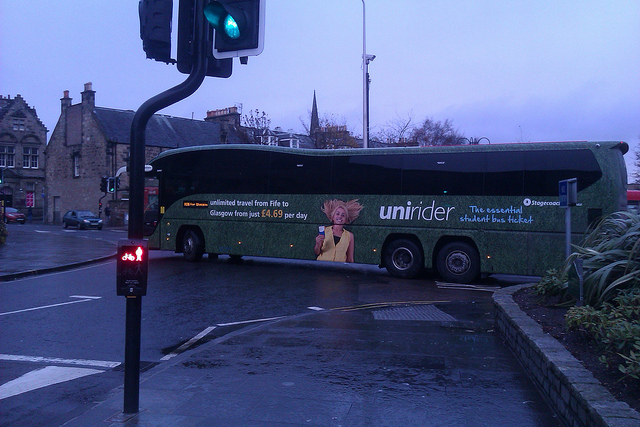How many cars can be seen in the image? In the image, there are a total of two cars visible alongside the prominently displayed bus. 